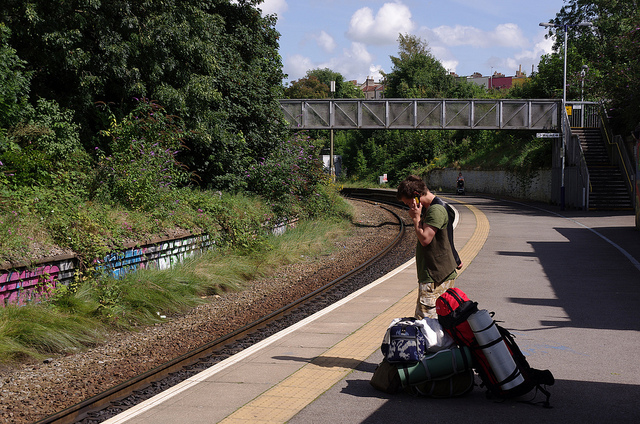Describe in detail the best route the person should take to get to the other side. To safely get to the other side, the person should walk down the platform towards the overhead bridge, ascend the stairs to the bridge, cross over the tracks using the bridge, then descend the stairs on the other side. This route ensures they avoid any potential dangers associated with crossing the tracks directly. 